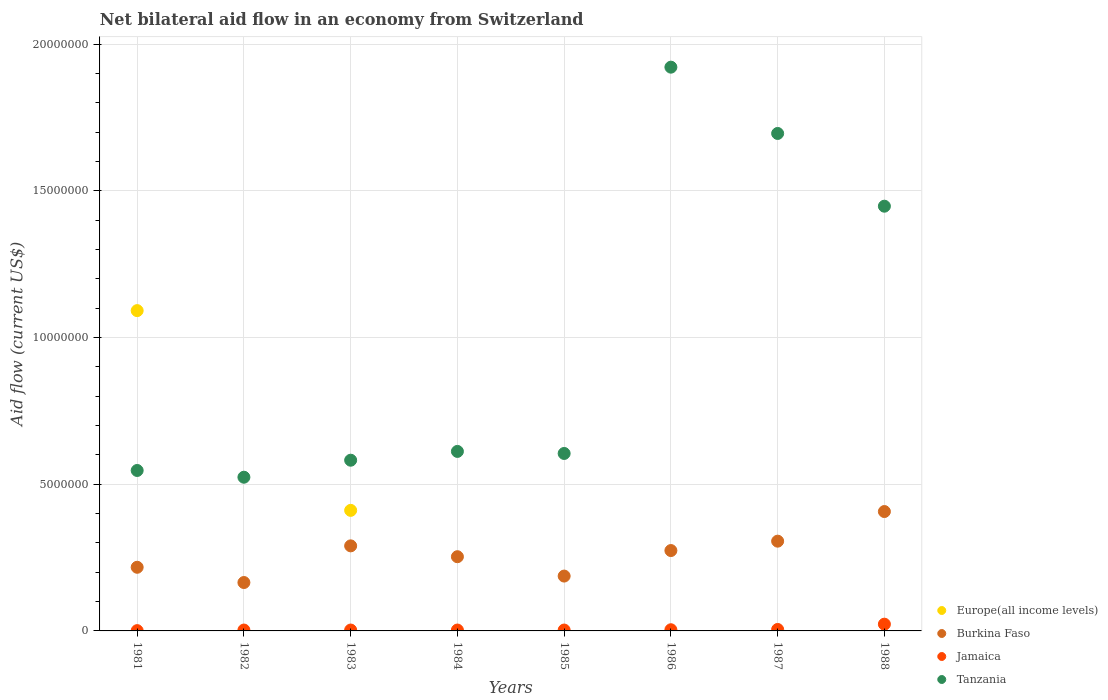What is the net bilateral aid flow in Jamaica in 1983?
Give a very brief answer. 3.00e+04. Across all years, what is the maximum net bilateral aid flow in Tanzania?
Provide a succinct answer. 1.92e+07. Across all years, what is the minimum net bilateral aid flow in Tanzania?
Offer a very short reply. 5.24e+06. What is the total net bilateral aid flow in Burkina Faso in the graph?
Provide a short and direct response. 2.10e+07. What is the difference between the net bilateral aid flow in Burkina Faso in 1982 and that in 1983?
Keep it short and to the point. -1.25e+06. What is the difference between the net bilateral aid flow in Europe(all income levels) in 1984 and the net bilateral aid flow in Burkina Faso in 1985?
Ensure brevity in your answer.  -1.87e+06. What is the average net bilateral aid flow in Jamaica per year?
Make the answer very short. 5.62e+04. In the year 1981, what is the difference between the net bilateral aid flow in Tanzania and net bilateral aid flow in Burkina Faso?
Your answer should be compact. 3.30e+06. In how many years, is the net bilateral aid flow in Europe(all income levels) greater than 15000000 US$?
Ensure brevity in your answer.  0. What is the ratio of the net bilateral aid flow in Burkina Faso in 1984 to that in 1988?
Offer a terse response. 0.62. Is the net bilateral aid flow in Jamaica in 1984 less than that in 1986?
Your response must be concise. Yes. What is the difference between the highest and the lowest net bilateral aid flow in Burkina Faso?
Your answer should be compact. 2.42e+06. Is it the case that in every year, the sum of the net bilateral aid flow in Jamaica and net bilateral aid flow in Europe(all income levels)  is greater than the sum of net bilateral aid flow in Burkina Faso and net bilateral aid flow in Tanzania?
Provide a succinct answer. No. Is the net bilateral aid flow in Jamaica strictly less than the net bilateral aid flow in Europe(all income levels) over the years?
Give a very brief answer. No. What is the difference between two consecutive major ticks on the Y-axis?
Offer a terse response. 5.00e+06. Does the graph contain any zero values?
Ensure brevity in your answer.  Yes. How are the legend labels stacked?
Keep it short and to the point. Vertical. What is the title of the graph?
Provide a short and direct response. Net bilateral aid flow in an economy from Switzerland. What is the label or title of the X-axis?
Ensure brevity in your answer.  Years. What is the label or title of the Y-axis?
Ensure brevity in your answer.  Aid flow (current US$). What is the Aid flow (current US$) in Europe(all income levels) in 1981?
Your response must be concise. 1.09e+07. What is the Aid flow (current US$) in Burkina Faso in 1981?
Your response must be concise. 2.17e+06. What is the Aid flow (current US$) in Jamaica in 1981?
Make the answer very short. 10000. What is the Aid flow (current US$) in Tanzania in 1981?
Offer a very short reply. 5.47e+06. What is the Aid flow (current US$) of Burkina Faso in 1982?
Provide a succinct answer. 1.65e+06. What is the Aid flow (current US$) of Tanzania in 1982?
Your response must be concise. 5.24e+06. What is the Aid flow (current US$) of Europe(all income levels) in 1983?
Provide a short and direct response. 4.11e+06. What is the Aid flow (current US$) in Burkina Faso in 1983?
Ensure brevity in your answer.  2.90e+06. What is the Aid flow (current US$) in Jamaica in 1983?
Provide a succinct answer. 3.00e+04. What is the Aid flow (current US$) in Tanzania in 1983?
Give a very brief answer. 5.82e+06. What is the Aid flow (current US$) in Europe(all income levels) in 1984?
Provide a short and direct response. 0. What is the Aid flow (current US$) of Burkina Faso in 1984?
Provide a succinct answer. 2.53e+06. What is the Aid flow (current US$) in Tanzania in 1984?
Make the answer very short. 6.12e+06. What is the Aid flow (current US$) in Burkina Faso in 1985?
Ensure brevity in your answer.  1.87e+06. What is the Aid flow (current US$) of Jamaica in 1985?
Make the answer very short. 3.00e+04. What is the Aid flow (current US$) in Tanzania in 1985?
Offer a terse response. 6.05e+06. What is the Aid flow (current US$) in Burkina Faso in 1986?
Ensure brevity in your answer.  2.74e+06. What is the Aid flow (current US$) of Tanzania in 1986?
Your response must be concise. 1.92e+07. What is the Aid flow (current US$) of Burkina Faso in 1987?
Offer a terse response. 3.06e+06. What is the Aid flow (current US$) in Tanzania in 1987?
Make the answer very short. 1.70e+07. What is the Aid flow (current US$) of Europe(all income levels) in 1988?
Your answer should be very brief. 0. What is the Aid flow (current US$) in Burkina Faso in 1988?
Your answer should be very brief. 4.07e+06. What is the Aid flow (current US$) in Tanzania in 1988?
Keep it short and to the point. 1.45e+07. Across all years, what is the maximum Aid flow (current US$) of Europe(all income levels)?
Give a very brief answer. 1.09e+07. Across all years, what is the maximum Aid flow (current US$) in Burkina Faso?
Ensure brevity in your answer.  4.07e+06. Across all years, what is the maximum Aid flow (current US$) in Jamaica?
Provide a short and direct response. 2.30e+05. Across all years, what is the maximum Aid flow (current US$) in Tanzania?
Provide a succinct answer. 1.92e+07. Across all years, what is the minimum Aid flow (current US$) in Europe(all income levels)?
Provide a succinct answer. 0. Across all years, what is the minimum Aid flow (current US$) of Burkina Faso?
Your response must be concise. 1.65e+06. Across all years, what is the minimum Aid flow (current US$) in Tanzania?
Offer a terse response. 5.24e+06. What is the total Aid flow (current US$) in Europe(all income levels) in the graph?
Your answer should be very brief. 1.50e+07. What is the total Aid flow (current US$) in Burkina Faso in the graph?
Provide a succinct answer. 2.10e+07. What is the total Aid flow (current US$) of Tanzania in the graph?
Your answer should be very brief. 7.94e+07. What is the difference between the Aid flow (current US$) of Burkina Faso in 1981 and that in 1982?
Your answer should be compact. 5.20e+05. What is the difference between the Aid flow (current US$) in Jamaica in 1981 and that in 1982?
Ensure brevity in your answer.  -2.00e+04. What is the difference between the Aid flow (current US$) of Tanzania in 1981 and that in 1982?
Your answer should be compact. 2.30e+05. What is the difference between the Aid flow (current US$) of Europe(all income levels) in 1981 and that in 1983?
Offer a very short reply. 6.81e+06. What is the difference between the Aid flow (current US$) in Burkina Faso in 1981 and that in 1983?
Your answer should be very brief. -7.30e+05. What is the difference between the Aid flow (current US$) of Jamaica in 1981 and that in 1983?
Provide a succinct answer. -2.00e+04. What is the difference between the Aid flow (current US$) of Tanzania in 1981 and that in 1983?
Ensure brevity in your answer.  -3.50e+05. What is the difference between the Aid flow (current US$) of Burkina Faso in 1981 and that in 1984?
Provide a short and direct response. -3.60e+05. What is the difference between the Aid flow (current US$) of Tanzania in 1981 and that in 1984?
Provide a succinct answer. -6.50e+05. What is the difference between the Aid flow (current US$) in Burkina Faso in 1981 and that in 1985?
Offer a terse response. 3.00e+05. What is the difference between the Aid flow (current US$) in Tanzania in 1981 and that in 1985?
Provide a short and direct response. -5.80e+05. What is the difference between the Aid flow (current US$) in Burkina Faso in 1981 and that in 1986?
Provide a short and direct response. -5.70e+05. What is the difference between the Aid flow (current US$) of Jamaica in 1981 and that in 1986?
Offer a very short reply. -3.00e+04. What is the difference between the Aid flow (current US$) of Tanzania in 1981 and that in 1986?
Make the answer very short. -1.38e+07. What is the difference between the Aid flow (current US$) in Burkina Faso in 1981 and that in 1987?
Offer a terse response. -8.90e+05. What is the difference between the Aid flow (current US$) of Jamaica in 1981 and that in 1987?
Give a very brief answer. -4.00e+04. What is the difference between the Aid flow (current US$) of Tanzania in 1981 and that in 1987?
Ensure brevity in your answer.  -1.15e+07. What is the difference between the Aid flow (current US$) of Burkina Faso in 1981 and that in 1988?
Give a very brief answer. -1.90e+06. What is the difference between the Aid flow (current US$) of Tanzania in 1981 and that in 1988?
Make the answer very short. -9.01e+06. What is the difference between the Aid flow (current US$) of Burkina Faso in 1982 and that in 1983?
Your answer should be very brief. -1.25e+06. What is the difference between the Aid flow (current US$) in Tanzania in 1982 and that in 1983?
Offer a terse response. -5.80e+05. What is the difference between the Aid flow (current US$) in Burkina Faso in 1982 and that in 1984?
Offer a very short reply. -8.80e+05. What is the difference between the Aid flow (current US$) of Jamaica in 1982 and that in 1984?
Ensure brevity in your answer.  0. What is the difference between the Aid flow (current US$) in Tanzania in 1982 and that in 1984?
Keep it short and to the point. -8.80e+05. What is the difference between the Aid flow (current US$) of Burkina Faso in 1982 and that in 1985?
Your answer should be very brief. -2.20e+05. What is the difference between the Aid flow (current US$) of Jamaica in 1982 and that in 1985?
Your response must be concise. 0. What is the difference between the Aid flow (current US$) of Tanzania in 1982 and that in 1985?
Your answer should be very brief. -8.10e+05. What is the difference between the Aid flow (current US$) in Burkina Faso in 1982 and that in 1986?
Make the answer very short. -1.09e+06. What is the difference between the Aid flow (current US$) of Jamaica in 1982 and that in 1986?
Your response must be concise. -10000. What is the difference between the Aid flow (current US$) in Tanzania in 1982 and that in 1986?
Make the answer very short. -1.40e+07. What is the difference between the Aid flow (current US$) in Burkina Faso in 1982 and that in 1987?
Your answer should be very brief. -1.41e+06. What is the difference between the Aid flow (current US$) in Tanzania in 1982 and that in 1987?
Your response must be concise. -1.17e+07. What is the difference between the Aid flow (current US$) of Burkina Faso in 1982 and that in 1988?
Ensure brevity in your answer.  -2.42e+06. What is the difference between the Aid flow (current US$) in Tanzania in 1982 and that in 1988?
Offer a very short reply. -9.24e+06. What is the difference between the Aid flow (current US$) in Jamaica in 1983 and that in 1984?
Your answer should be very brief. 0. What is the difference between the Aid flow (current US$) in Tanzania in 1983 and that in 1984?
Provide a short and direct response. -3.00e+05. What is the difference between the Aid flow (current US$) of Burkina Faso in 1983 and that in 1985?
Keep it short and to the point. 1.03e+06. What is the difference between the Aid flow (current US$) of Tanzania in 1983 and that in 1985?
Make the answer very short. -2.30e+05. What is the difference between the Aid flow (current US$) in Tanzania in 1983 and that in 1986?
Provide a succinct answer. -1.34e+07. What is the difference between the Aid flow (current US$) in Jamaica in 1983 and that in 1987?
Keep it short and to the point. -2.00e+04. What is the difference between the Aid flow (current US$) of Tanzania in 1983 and that in 1987?
Offer a very short reply. -1.11e+07. What is the difference between the Aid flow (current US$) in Burkina Faso in 1983 and that in 1988?
Your answer should be compact. -1.17e+06. What is the difference between the Aid flow (current US$) in Tanzania in 1983 and that in 1988?
Ensure brevity in your answer.  -8.66e+06. What is the difference between the Aid flow (current US$) of Jamaica in 1984 and that in 1985?
Your response must be concise. 0. What is the difference between the Aid flow (current US$) of Tanzania in 1984 and that in 1985?
Provide a short and direct response. 7.00e+04. What is the difference between the Aid flow (current US$) in Tanzania in 1984 and that in 1986?
Provide a succinct answer. -1.31e+07. What is the difference between the Aid flow (current US$) of Burkina Faso in 1984 and that in 1987?
Ensure brevity in your answer.  -5.30e+05. What is the difference between the Aid flow (current US$) of Tanzania in 1984 and that in 1987?
Give a very brief answer. -1.08e+07. What is the difference between the Aid flow (current US$) in Burkina Faso in 1984 and that in 1988?
Your answer should be very brief. -1.54e+06. What is the difference between the Aid flow (current US$) in Tanzania in 1984 and that in 1988?
Your response must be concise. -8.36e+06. What is the difference between the Aid flow (current US$) of Burkina Faso in 1985 and that in 1986?
Provide a succinct answer. -8.70e+05. What is the difference between the Aid flow (current US$) in Tanzania in 1985 and that in 1986?
Your answer should be very brief. -1.32e+07. What is the difference between the Aid flow (current US$) of Burkina Faso in 1985 and that in 1987?
Offer a terse response. -1.19e+06. What is the difference between the Aid flow (current US$) of Tanzania in 1985 and that in 1987?
Keep it short and to the point. -1.09e+07. What is the difference between the Aid flow (current US$) of Burkina Faso in 1985 and that in 1988?
Your answer should be very brief. -2.20e+06. What is the difference between the Aid flow (current US$) in Jamaica in 1985 and that in 1988?
Ensure brevity in your answer.  -2.00e+05. What is the difference between the Aid flow (current US$) of Tanzania in 1985 and that in 1988?
Keep it short and to the point. -8.43e+06. What is the difference between the Aid flow (current US$) of Burkina Faso in 1986 and that in 1987?
Your response must be concise. -3.20e+05. What is the difference between the Aid flow (current US$) of Jamaica in 1986 and that in 1987?
Offer a terse response. -10000. What is the difference between the Aid flow (current US$) of Tanzania in 1986 and that in 1987?
Provide a succinct answer. 2.26e+06. What is the difference between the Aid flow (current US$) in Burkina Faso in 1986 and that in 1988?
Your answer should be compact. -1.33e+06. What is the difference between the Aid flow (current US$) of Jamaica in 1986 and that in 1988?
Your response must be concise. -1.90e+05. What is the difference between the Aid flow (current US$) in Tanzania in 1986 and that in 1988?
Provide a short and direct response. 4.74e+06. What is the difference between the Aid flow (current US$) in Burkina Faso in 1987 and that in 1988?
Make the answer very short. -1.01e+06. What is the difference between the Aid flow (current US$) of Tanzania in 1987 and that in 1988?
Make the answer very short. 2.48e+06. What is the difference between the Aid flow (current US$) in Europe(all income levels) in 1981 and the Aid flow (current US$) in Burkina Faso in 1982?
Your answer should be very brief. 9.27e+06. What is the difference between the Aid flow (current US$) in Europe(all income levels) in 1981 and the Aid flow (current US$) in Jamaica in 1982?
Offer a terse response. 1.09e+07. What is the difference between the Aid flow (current US$) of Europe(all income levels) in 1981 and the Aid flow (current US$) of Tanzania in 1982?
Offer a terse response. 5.68e+06. What is the difference between the Aid flow (current US$) in Burkina Faso in 1981 and the Aid flow (current US$) in Jamaica in 1982?
Keep it short and to the point. 2.14e+06. What is the difference between the Aid flow (current US$) of Burkina Faso in 1981 and the Aid flow (current US$) of Tanzania in 1982?
Offer a terse response. -3.07e+06. What is the difference between the Aid flow (current US$) in Jamaica in 1981 and the Aid flow (current US$) in Tanzania in 1982?
Give a very brief answer. -5.23e+06. What is the difference between the Aid flow (current US$) in Europe(all income levels) in 1981 and the Aid flow (current US$) in Burkina Faso in 1983?
Make the answer very short. 8.02e+06. What is the difference between the Aid flow (current US$) of Europe(all income levels) in 1981 and the Aid flow (current US$) of Jamaica in 1983?
Your answer should be very brief. 1.09e+07. What is the difference between the Aid flow (current US$) in Europe(all income levels) in 1981 and the Aid flow (current US$) in Tanzania in 1983?
Provide a short and direct response. 5.10e+06. What is the difference between the Aid flow (current US$) of Burkina Faso in 1981 and the Aid flow (current US$) of Jamaica in 1983?
Keep it short and to the point. 2.14e+06. What is the difference between the Aid flow (current US$) in Burkina Faso in 1981 and the Aid flow (current US$) in Tanzania in 1983?
Your answer should be compact. -3.65e+06. What is the difference between the Aid flow (current US$) of Jamaica in 1981 and the Aid flow (current US$) of Tanzania in 1983?
Offer a very short reply. -5.81e+06. What is the difference between the Aid flow (current US$) of Europe(all income levels) in 1981 and the Aid flow (current US$) of Burkina Faso in 1984?
Keep it short and to the point. 8.39e+06. What is the difference between the Aid flow (current US$) of Europe(all income levels) in 1981 and the Aid flow (current US$) of Jamaica in 1984?
Provide a succinct answer. 1.09e+07. What is the difference between the Aid flow (current US$) of Europe(all income levels) in 1981 and the Aid flow (current US$) of Tanzania in 1984?
Make the answer very short. 4.80e+06. What is the difference between the Aid flow (current US$) in Burkina Faso in 1981 and the Aid flow (current US$) in Jamaica in 1984?
Offer a very short reply. 2.14e+06. What is the difference between the Aid flow (current US$) of Burkina Faso in 1981 and the Aid flow (current US$) of Tanzania in 1984?
Provide a succinct answer. -3.95e+06. What is the difference between the Aid flow (current US$) in Jamaica in 1981 and the Aid flow (current US$) in Tanzania in 1984?
Your response must be concise. -6.11e+06. What is the difference between the Aid flow (current US$) of Europe(all income levels) in 1981 and the Aid flow (current US$) of Burkina Faso in 1985?
Your answer should be compact. 9.05e+06. What is the difference between the Aid flow (current US$) in Europe(all income levels) in 1981 and the Aid flow (current US$) in Jamaica in 1985?
Offer a terse response. 1.09e+07. What is the difference between the Aid flow (current US$) of Europe(all income levels) in 1981 and the Aid flow (current US$) of Tanzania in 1985?
Ensure brevity in your answer.  4.87e+06. What is the difference between the Aid flow (current US$) in Burkina Faso in 1981 and the Aid flow (current US$) in Jamaica in 1985?
Your answer should be very brief. 2.14e+06. What is the difference between the Aid flow (current US$) of Burkina Faso in 1981 and the Aid flow (current US$) of Tanzania in 1985?
Provide a short and direct response. -3.88e+06. What is the difference between the Aid flow (current US$) in Jamaica in 1981 and the Aid flow (current US$) in Tanzania in 1985?
Keep it short and to the point. -6.04e+06. What is the difference between the Aid flow (current US$) of Europe(all income levels) in 1981 and the Aid flow (current US$) of Burkina Faso in 1986?
Provide a short and direct response. 8.18e+06. What is the difference between the Aid flow (current US$) of Europe(all income levels) in 1981 and the Aid flow (current US$) of Jamaica in 1986?
Give a very brief answer. 1.09e+07. What is the difference between the Aid flow (current US$) in Europe(all income levels) in 1981 and the Aid flow (current US$) in Tanzania in 1986?
Your answer should be very brief. -8.30e+06. What is the difference between the Aid flow (current US$) of Burkina Faso in 1981 and the Aid flow (current US$) of Jamaica in 1986?
Provide a succinct answer. 2.13e+06. What is the difference between the Aid flow (current US$) in Burkina Faso in 1981 and the Aid flow (current US$) in Tanzania in 1986?
Make the answer very short. -1.70e+07. What is the difference between the Aid flow (current US$) of Jamaica in 1981 and the Aid flow (current US$) of Tanzania in 1986?
Your response must be concise. -1.92e+07. What is the difference between the Aid flow (current US$) of Europe(all income levels) in 1981 and the Aid flow (current US$) of Burkina Faso in 1987?
Provide a short and direct response. 7.86e+06. What is the difference between the Aid flow (current US$) of Europe(all income levels) in 1981 and the Aid flow (current US$) of Jamaica in 1987?
Make the answer very short. 1.09e+07. What is the difference between the Aid flow (current US$) of Europe(all income levels) in 1981 and the Aid flow (current US$) of Tanzania in 1987?
Offer a terse response. -6.04e+06. What is the difference between the Aid flow (current US$) of Burkina Faso in 1981 and the Aid flow (current US$) of Jamaica in 1987?
Provide a succinct answer. 2.12e+06. What is the difference between the Aid flow (current US$) in Burkina Faso in 1981 and the Aid flow (current US$) in Tanzania in 1987?
Offer a very short reply. -1.48e+07. What is the difference between the Aid flow (current US$) in Jamaica in 1981 and the Aid flow (current US$) in Tanzania in 1987?
Keep it short and to the point. -1.70e+07. What is the difference between the Aid flow (current US$) of Europe(all income levels) in 1981 and the Aid flow (current US$) of Burkina Faso in 1988?
Offer a very short reply. 6.85e+06. What is the difference between the Aid flow (current US$) in Europe(all income levels) in 1981 and the Aid flow (current US$) in Jamaica in 1988?
Your response must be concise. 1.07e+07. What is the difference between the Aid flow (current US$) of Europe(all income levels) in 1981 and the Aid flow (current US$) of Tanzania in 1988?
Provide a short and direct response. -3.56e+06. What is the difference between the Aid flow (current US$) in Burkina Faso in 1981 and the Aid flow (current US$) in Jamaica in 1988?
Offer a very short reply. 1.94e+06. What is the difference between the Aid flow (current US$) of Burkina Faso in 1981 and the Aid flow (current US$) of Tanzania in 1988?
Give a very brief answer. -1.23e+07. What is the difference between the Aid flow (current US$) in Jamaica in 1981 and the Aid flow (current US$) in Tanzania in 1988?
Provide a short and direct response. -1.45e+07. What is the difference between the Aid flow (current US$) of Burkina Faso in 1982 and the Aid flow (current US$) of Jamaica in 1983?
Provide a short and direct response. 1.62e+06. What is the difference between the Aid flow (current US$) in Burkina Faso in 1982 and the Aid flow (current US$) in Tanzania in 1983?
Your response must be concise. -4.17e+06. What is the difference between the Aid flow (current US$) of Jamaica in 1982 and the Aid flow (current US$) of Tanzania in 1983?
Your response must be concise. -5.79e+06. What is the difference between the Aid flow (current US$) of Burkina Faso in 1982 and the Aid flow (current US$) of Jamaica in 1984?
Give a very brief answer. 1.62e+06. What is the difference between the Aid flow (current US$) in Burkina Faso in 1982 and the Aid flow (current US$) in Tanzania in 1984?
Provide a succinct answer. -4.47e+06. What is the difference between the Aid flow (current US$) in Jamaica in 1982 and the Aid flow (current US$) in Tanzania in 1984?
Your answer should be compact. -6.09e+06. What is the difference between the Aid flow (current US$) of Burkina Faso in 1982 and the Aid flow (current US$) of Jamaica in 1985?
Offer a terse response. 1.62e+06. What is the difference between the Aid flow (current US$) in Burkina Faso in 1982 and the Aid flow (current US$) in Tanzania in 1985?
Offer a very short reply. -4.40e+06. What is the difference between the Aid flow (current US$) in Jamaica in 1982 and the Aid flow (current US$) in Tanzania in 1985?
Your answer should be compact. -6.02e+06. What is the difference between the Aid flow (current US$) of Burkina Faso in 1982 and the Aid flow (current US$) of Jamaica in 1986?
Your answer should be compact. 1.61e+06. What is the difference between the Aid flow (current US$) of Burkina Faso in 1982 and the Aid flow (current US$) of Tanzania in 1986?
Give a very brief answer. -1.76e+07. What is the difference between the Aid flow (current US$) in Jamaica in 1982 and the Aid flow (current US$) in Tanzania in 1986?
Provide a succinct answer. -1.92e+07. What is the difference between the Aid flow (current US$) in Burkina Faso in 1982 and the Aid flow (current US$) in Jamaica in 1987?
Offer a very short reply. 1.60e+06. What is the difference between the Aid flow (current US$) of Burkina Faso in 1982 and the Aid flow (current US$) of Tanzania in 1987?
Ensure brevity in your answer.  -1.53e+07. What is the difference between the Aid flow (current US$) of Jamaica in 1982 and the Aid flow (current US$) of Tanzania in 1987?
Provide a short and direct response. -1.69e+07. What is the difference between the Aid flow (current US$) in Burkina Faso in 1982 and the Aid flow (current US$) in Jamaica in 1988?
Offer a very short reply. 1.42e+06. What is the difference between the Aid flow (current US$) of Burkina Faso in 1982 and the Aid flow (current US$) of Tanzania in 1988?
Provide a short and direct response. -1.28e+07. What is the difference between the Aid flow (current US$) in Jamaica in 1982 and the Aid flow (current US$) in Tanzania in 1988?
Offer a very short reply. -1.44e+07. What is the difference between the Aid flow (current US$) of Europe(all income levels) in 1983 and the Aid flow (current US$) of Burkina Faso in 1984?
Provide a succinct answer. 1.58e+06. What is the difference between the Aid flow (current US$) in Europe(all income levels) in 1983 and the Aid flow (current US$) in Jamaica in 1984?
Keep it short and to the point. 4.08e+06. What is the difference between the Aid flow (current US$) of Europe(all income levels) in 1983 and the Aid flow (current US$) of Tanzania in 1984?
Provide a succinct answer. -2.01e+06. What is the difference between the Aid flow (current US$) in Burkina Faso in 1983 and the Aid flow (current US$) in Jamaica in 1984?
Give a very brief answer. 2.87e+06. What is the difference between the Aid flow (current US$) of Burkina Faso in 1983 and the Aid flow (current US$) of Tanzania in 1984?
Give a very brief answer. -3.22e+06. What is the difference between the Aid flow (current US$) in Jamaica in 1983 and the Aid flow (current US$) in Tanzania in 1984?
Keep it short and to the point. -6.09e+06. What is the difference between the Aid flow (current US$) of Europe(all income levels) in 1983 and the Aid flow (current US$) of Burkina Faso in 1985?
Give a very brief answer. 2.24e+06. What is the difference between the Aid flow (current US$) of Europe(all income levels) in 1983 and the Aid flow (current US$) of Jamaica in 1985?
Provide a succinct answer. 4.08e+06. What is the difference between the Aid flow (current US$) in Europe(all income levels) in 1983 and the Aid flow (current US$) in Tanzania in 1985?
Keep it short and to the point. -1.94e+06. What is the difference between the Aid flow (current US$) of Burkina Faso in 1983 and the Aid flow (current US$) of Jamaica in 1985?
Offer a very short reply. 2.87e+06. What is the difference between the Aid flow (current US$) in Burkina Faso in 1983 and the Aid flow (current US$) in Tanzania in 1985?
Offer a terse response. -3.15e+06. What is the difference between the Aid flow (current US$) of Jamaica in 1983 and the Aid flow (current US$) of Tanzania in 1985?
Offer a terse response. -6.02e+06. What is the difference between the Aid flow (current US$) of Europe(all income levels) in 1983 and the Aid flow (current US$) of Burkina Faso in 1986?
Offer a terse response. 1.37e+06. What is the difference between the Aid flow (current US$) of Europe(all income levels) in 1983 and the Aid flow (current US$) of Jamaica in 1986?
Offer a terse response. 4.07e+06. What is the difference between the Aid flow (current US$) in Europe(all income levels) in 1983 and the Aid flow (current US$) in Tanzania in 1986?
Provide a short and direct response. -1.51e+07. What is the difference between the Aid flow (current US$) of Burkina Faso in 1983 and the Aid flow (current US$) of Jamaica in 1986?
Keep it short and to the point. 2.86e+06. What is the difference between the Aid flow (current US$) of Burkina Faso in 1983 and the Aid flow (current US$) of Tanzania in 1986?
Offer a very short reply. -1.63e+07. What is the difference between the Aid flow (current US$) in Jamaica in 1983 and the Aid flow (current US$) in Tanzania in 1986?
Ensure brevity in your answer.  -1.92e+07. What is the difference between the Aid flow (current US$) in Europe(all income levels) in 1983 and the Aid flow (current US$) in Burkina Faso in 1987?
Give a very brief answer. 1.05e+06. What is the difference between the Aid flow (current US$) in Europe(all income levels) in 1983 and the Aid flow (current US$) in Jamaica in 1987?
Offer a very short reply. 4.06e+06. What is the difference between the Aid flow (current US$) of Europe(all income levels) in 1983 and the Aid flow (current US$) of Tanzania in 1987?
Your answer should be compact. -1.28e+07. What is the difference between the Aid flow (current US$) of Burkina Faso in 1983 and the Aid flow (current US$) of Jamaica in 1987?
Keep it short and to the point. 2.85e+06. What is the difference between the Aid flow (current US$) in Burkina Faso in 1983 and the Aid flow (current US$) in Tanzania in 1987?
Offer a very short reply. -1.41e+07. What is the difference between the Aid flow (current US$) in Jamaica in 1983 and the Aid flow (current US$) in Tanzania in 1987?
Give a very brief answer. -1.69e+07. What is the difference between the Aid flow (current US$) of Europe(all income levels) in 1983 and the Aid flow (current US$) of Jamaica in 1988?
Offer a terse response. 3.88e+06. What is the difference between the Aid flow (current US$) in Europe(all income levels) in 1983 and the Aid flow (current US$) in Tanzania in 1988?
Offer a terse response. -1.04e+07. What is the difference between the Aid flow (current US$) in Burkina Faso in 1983 and the Aid flow (current US$) in Jamaica in 1988?
Your answer should be very brief. 2.67e+06. What is the difference between the Aid flow (current US$) in Burkina Faso in 1983 and the Aid flow (current US$) in Tanzania in 1988?
Provide a succinct answer. -1.16e+07. What is the difference between the Aid flow (current US$) of Jamaica in 1983 and the Aid flow (current US$) of Tanzania in 1988?
Keep it short and to the point. -1.44e+07. What is the difference between the Aid flow (current US$) in Burkina Faso in 1984 and the Aid flow (current US$) in Jamaica in 1985?
Your answer should be very brief. 2.50e+06. What is the difference between the Aid flow (current US$) of Burkina Faso in 1984 and the Aid flow (current US$) of Tanzania in 1985?
Provide a succinct answer. -3.52e+06. What is the difference between the Aid flow (current US$) in Jamaica in 1984 and the Aid flow (current US$) in Tanzania in 1985?
Keep it short and to the point. -6.02e+06. What is the difference between the Aid flow (current US$) in Burkina Faso in 1984 and the Aid flow (current US$) in Jamaica in 1986?
Ensure brevity in your answer.  2.49e+06. What is the difference between the Aid flow (current US$) of Burkina Faso in 1984 and the Aid flow (current US$) of Tanzania in 1986?
Your response must be concise. -1.67e+07. What is the difference between the Aid flow (current US$) in Jamaica in 1984 and the Aid flow (current US$) in Tanzania in 1986?
Your response must be concise. -1.92e+07. What is the difference between the Aid flow (current US$) of Burkina Faso in 1984 and the Aid flow (current US$) of Jamaica in 1987?
Your answer should be very brief. 2.48e+06. What is the difference between the Aid flow (current US$) in Burkina Faso in 1984 and the Aid flow (current US$) in Tanzania in 1987?
Keep it short and to the point. -1.44e+07. What is the difference between the Aid flow (current US$) in Jamaica in 1984 and the Aid flow (current US$) in Tanzania in 1987?
Provide a succinct answer. -1.69e+07. What is the difference between the Aid flow (current US$) of Burkina Faso in 1984 and the Aid flow (current US$) of Jamaica in 1988?
Your answer should be compact. 2.30e+06. What is the difference between the Aid flow (current US$) in Burkina Faso in 1984 and the Aid flow (current US$) in Tanzania in 1988?
Ensure brevity in your answer.  -1.20e+07. What is the difference between the Aid flow (current US$) in Jamaica in 1984 and the Aid flow (current US$) in Tanzania in 1988?
Your answer should be compact. -1.44e+07. What is the difference between the Aid flow (current US$) of Burkina Faso in 1985 and the Aid flow (current US$) of Jamaica in 1986?
Keep it short and to the point. 1.83e+06. What is the difference between the Aid flow (current US$) in Burkina Faso in 1985 and the Aid flow (current US$) in Tanzania in 1986?
Provide a short and direct response. -1.74e+07. What is the difference between the Aid flow (current US$) in Jamaica in 1985 and the Aid flow (current US$) in Tanzania in 1986?
Offer a very short reply. -1.92e+07. What is the difference between the Aid flow (current US$) in Burkina Faso in 1985 and the Aid flow (current US$) in Jamaica in 1987?
Provide a short and direct response. 1.82e+06. What is the difference between the Aid flow (current US$) in Burkina Faso in 1985 and the Aid flow (current US$) in Tanzania in 1987?
Make the answer very short. -1.51e+07. What is the difference between the Aid flow (current US$) of Jamaica in 1985 and the Aid flow (current US$) of Tanzania in 1987?
Make the answer very short. -1.69e+07. What is the difference between the Aid flow (current US$) of Burkina Faso in 1985 and the Aid flow (current US$) of Jamaica in 1988?
Make the answer very short. 1.64e+06. What is the difference between the Aid flow (current US$) in Burkina Faso in 1985 and the Aid flow (current US$) in Tanzania in 1988?
Provide a short and direct response. -1.26e+07. What is the difference between the Aid flow (current US$) of Jamaica in 1985 and the Aid flow (current US$) of Tanzania in 1988?
Make the answer very short. -1.44e+07. What is the difference between the Aid flow (current US$) of Burkina Faso in 1986 and the Aid flow (current US$) of Jamaica in 1987?
Keep it short and to the point. 2.69e+06. What is the difference between the Aid flow (current US$) in Burkina Faso in 1986 and the Aid flow (current US$) in Tanzania in 1987?
Make the answer very short. -1.42e+07. What is the difference between the Aid flow (current US$) of Jamaica in 1986 and the Aid flow (current US$) of Tanzania in 1987?
Offer a very short reply. -1.69e+07. What is the difference between the Aid flow (current US$) in Burkina Faso in 1986 and the Aid flow (current US$) in Jamaica in 1988?
Provide a short and direct response. 2.51e+06. What is the difference between the Aid flow (current US$) in Burkina Faso in 1986 and the Aid flow (current US$) in Tanzania in 1988?
Make the answer very short. -1.17e+07. What is the difference between the Aid flow (current US$) of Jamaica in 1986 and the Aid flow (current US$) of Tanzania in 1988?
Provide a succinct answer. -1.44e+07. What is the difference between the Aid flow (current US$) in Burkina Faso in 1987 and the Aid flow (current US$) in Jamaica in 1988?
Offer a very short reply. 2.83e+06. What is the difference between the Aid flow (current US$) in Burkina Faso in 1987 and the Aid flow (current US$) in Tanzania in 1988?
Offer a very short reply. -1.14e+07. What is the difference between the Aid flow (current US$) in Jamaica in 1987 and the Aid flow (current US$) in Tanzania in 1988?
Offer a very short reply. -1.44e+07. What is the average Aid flow (current US$) in Europe(all income levels) per year?
Keep it short and to the point. 1.88e+06. What is the average Aid flow (current US$) of Burkina Faso per year?
Your answer should be compact. 2.62e+06. What is the average Aid flow (current US$) of Jamaica per year?
Make the answer very short. 5.62e+04. What is the average Aid flow (current US$) in Tanzania per year?
Ensure brevity in your answer.  9.92e+06. In the year 1981, what is the difference between the Aid flow (current US$) in Europe(all income levels) and Aid flow (current US$) in Burkina Faso?
Offer a terse response. 8.75e+06. In the year 1981, what is the difference between the Aid flow (current US$) in Europe(all income levels) and Aid flow (current US$) in Jamaica?
Provide a succinct answer. 1.09e+07. In the year 1981, what is the difference between the Aid flow (current US$) in Europe(all income levels) and Aid flow (current US$) in Tanzania?
Provide a short and direct response. 5.45e+06. In the year 1981, what is the difference between the Aid flow (current US$) in Burkina Faso and Aid flow (current US$) in Jamaica?
Your answer should be very brief. 2.16e+06. In the year 1981, what is the difference between the Aid flow (current US$) of Burkina Faso and Aid flow (current US$) of Tanzania?
Give a very brief answer. -3.30e+06. In the year 1981, what is the difference between the Aid flow (current US$) in Jamaica and Aid flow (current US$) in Tanzania?
Make the answer very short. -5.46e+06. In the year 1982, what is the difference between the Aid flow (current US$) of Burkina Faso and Aid flow (current US$) of Jamaica?
Provide a succinct answer. 1.62e+06. In the year 1982, what is the difference between the Aid flow (current US$) in Burkina Faso and Aid flow (current US$) in Tanzania?
Keep it short and to the point. -3.59e+06. In the year 1982, what is the difference between the Aid flow (current US$) of Jamaica and Aid flow (current US$) of Tanzania?
Provide a succinct answer. -5.21e+06. In the year 1983, what is the difference between the Aid flow (current US$) of Europe(all income levels) and Aid flow (current US$) of Burkina Faso?
Keep it short and to the point. 1.21e+06. In the year 1983, what is the difference between the Aid flow (current US$) of Europe(all income levels) and Aid flow (current US$) of Jamaica?
Make the answer very short. 4.08e+06. In the year 1983, what is the difference between the Aid flow (current US$) in Europe(all income levels) and Aid flow (current US$) in Tanzania?
Your answer should be compact. -1.71e+06. In the year 1983, what is the difference between the Aid flow (current US$) in Burkina Faso and Aid flow (current US$) in Jamaica?
Give a very brief answer. 2.87e+06. In the year 1983, what is the difference between the Aid flow (current US$) in Burkina Faso and Aid flow (current US$) in Tanzania?
Provide a succinct answer. -2.92e+06. In the year 1983, what is the difference between the Aid flow (current US$) in Jamaica and Aid flow (current US$) in Tanzania?
Make the answer very short. -5.79e+06. In the year 1984, what is the difference between the Aid flow (current US$) of Burkina Faso and Aid flow (current US$) of Jamaica?
Provide a short and direct response. 2.50e+06. In the year 1984, what is the difference between the Aid flow (current US$) of Burkina Faso and Aid flow (current US$) of Tanzania?
Offer a very short reply. -3.59e+06. In the year 1984, what is the difference between the Aid flow (current US$) in Jamaica and Aid flow (current US$) in Tanzania?
Your answer should be very brief. -6.09e+06. In the year 1985, what is the difference between the Aid flow (current US$) of Burkina Faso and Aid flow (current US$) of Jamaica?
Keep it short and to the point. 1.84e+06. In the year 1985, what is the difference between the Aid flow (current US$) of Burkina Faso and Aid flow (current US$) of Tanzania?
Your answer should be very brief. -4.18e+06. In the year 1985, what is the difference between the Aid flow (current US$) of Jamaica and Aid flow (current US$) of Tanzania?
Your response must be concise. -6.02e+06. In the year 1986, what is the difference between the Aid flow (current US$) of Burkina Faso and Aid flow (current US$) of Jamaica?
Your answer should be very brief. 2.70e+06. In the year 1986, what is the difference between the Aid flow (current US$) of Burkina Faso and Aid flow (current US$) of Tanzania?
Give a very brief answer. -1.65e+07. In the year 1986, what is the difference between the Aid flow (current US$) in Jamaica and Aid flow (current US$) in Tanzania?
Give a very brief answer. -1.92e+07. In the year 1987, what is the difference between the Aid flow (current US$) in Burkina Faso and Aid flow (current US$) in Jamaica?
Offer a very short reply. 3.01e+06. In the year 1987, what is the difference between the Aid flow (current US$) in Burkina Faso and Aid flow (current US$) in Tanzania?
Your answer should be compact. -1.39e+07. In the year 1987, what is the difference between the Aid flow (current US$) in Jamaica and Aid flow (current US$) in Tanzania?
Ensure brevity in your answer.  -1.69e+07. In the year 1988, what is the difference between the Aid flow (current US$) of Burkina Faso and Aid flow (current US$) of Jamaica?
Offer a terse response. 3.84e+06. In the year 1988, what is the difference between the Aid flow (current US$) in Burkina Faso and Aid flow (current US$) in Tanzania?
Provide a short and direct response. -1.04e+07. In the year 1988, what is the difference between the Aid flow (current US$) in Jamaica and Aid flow (current US$) in Tanzania?
Provide a short and direct response. -1.42e+07. What is the ratio of the Aid flow (current US$) of Burkina Faso in 1981 to that in 1982?
Offer a very short reply. 1.32. What is the ratio of the Aid flow (current US$) in Tanzania in 1981 to that in 1982?
Provide a short and direct response. 1.04. What is the ratio of the Aid flow (current US$) of Europe(all income levels) in 1981 to that in 1983?
Offer a terse response. 2.66. What is the ratio of the Aid flow (current US$) in Burkina Faso in 1981 to that in 1983?
Provide a succinct answer. 0.75. What is the ratio of the Aid flow (current US$) in Jamaica in 1981 to that in 1983?
Make the answer very short. 0.33. What is the ratio of the Aid flow (current US$) of Tanzania in 1981 to that in 1983?
Your response must be concise. 0.94. What is the ratio of the Aid flow (current US$) of Burkina Faso in 1981 to that in 1984?
Provide a succinct answer. 0.86. What is the ratio of the Aid flow (current US$) in Tanzania in 1981 to that in 1984?
Offer a terse response. 0.89. What is the ratio of the Aid flow (current US$) of Burkina Faso in 1981 to that in 1985?
Make the answer very short. 1.16. What is the ratio of the Aid flow (current US$) in Jamaica in 1981 to that in 1985?
Keep it short and to the point. 0.33. What is the ratio of the Aid flow (current US$) in Tanzania in 1981 to that in 1985?
Keep it short and to the point. 0.9. What is the ratio of the Aid flow (current US$) in Burkina Faso in 1981 to that in 1986?
Provide a succinct answer. 0.79. What is the ratio of the Aid flow (current US$) of Tanzania in 1981 to that in 1986?
Your response must be concise. 0.28. What is the ratio of the Aid flow (current US$) of Burkina Faso in 1981 to that in 1987?
Keep it short and to the point. 0.71. What is the ratio of the Aid flow (current US$) in Tanzania in 1981 to that in 1987?
Provide a short and direct response. 0.32. What is the ratio of the Aid flow (current US$) in Burkina Faso in 1981 to that in 1988?
Ensure brevity in your answer.  0.53. What is the ratio of the Aid flow (current US$) of Jamaica in 1981 to that in 1988?
Ensure brevity in your answer.  0.04. What is the ratio of the Aid flow (current US$) in Tanzania in 1981 to that in 1988?
Your answer should be compact. 0.38. What is the ratio of the Aid flow (current US$) in Burkina Faso in 1982 to that in 1983?
Your response must be concise. 0.57. What is the ratio of the Aid flow (current US$) of Tanzania in 1982 to that in 1983?
Offer a terse response. 0.9. What is the ratio of the Aid flow (current US$) of Burkina Faso in 1982 to that in 1984?
Ensure brevity in your answer.  0.65. What is the ratio of the Aid flow (current US$) in Jamaica in 1982 to that in 1984?
Ensure brevity in your answer.  1. What is the ratio of the Aid flow (current US$) in Tanzania in 1982 to that in 1984?
Your answer should be very brief. 0.86. What is the ratio of the Aid flow (current US$) in Burkina Faso in 1982 to that in 1985?
Give a very brief answer. 0.88. What is the ratio of the Aid flow (current US$) of Tanzania in 1982 to that in 1985?
Your answer should be compact. 0.87. What is the ratio of the Aid flow (current US$) in Burkina Faso in 1982 to that in 1986?
Give a very brief answer. 0.6. What is the ratio of the Aid flow (current US$) in Tanzania in 1982 to that in 1986?
Your response must be concise. 0.27. What is the ratio of the Aid flow (current US$) of Burkina Faso in 1982 to that in 1987?
Your response must be concise. 0.54. What is the ratio of the Aid flow (current US$) of Tanzania in 1982 to that in 1987?
Provide a succinct answer. 0.31. What is the ratio of the Aid flow (current US$) in Burkina Faso in 1982 to that in 1988?
Provide a short and direct response. 0.41. What is the ratio of the Aid flow (current US$) of Jamaica in 1982 to that in 1988?
Make the answer very short. 0.13. What is the ratio of the Aid flow (current US$) of Tanzania in 1982 to that in 1988?
Ensure brevity in your answer.  0.36. What is the ratio of the Aid flow (current US$) of Burkina Faso in 1983 to that in 1984?
Your answer should be compact. 1.15. What is the ratio of the Aid flow (current US$) in Jamaica in 1983 to that in 1984?
Make the answer very short. 1. What is the ratio of the Aid flow (current US$) of Tanzania in 1983 to that in 1984?
Your answer should be very brief. 0.95. What is the ratio of the Aid flow (current US$) in Burkina Faso in 1983 to that in 1985?
Offer a very short reply. 1.55. What is the ratio of the Aid flow (current US$) in Jamaica in 1983 to that in 1985?
Your answer should be compact. 1. What is the ratio of the Aid flow (current US$) in Burkina Faso in 1983 to that in 1986?
Offer a very short reply. 1.06. What is the ratio of the Aid flow (current US$) in Tanzania in 1983 to that in 1986?
Offer a terse response. 0.3. What is the ratio of the Aid flow (current US$) in Burkina Faso in 1983 to that in 1987?
Your response must be concise. 0.95. What is the ratio of the Aid flow (current US$) of Jamaica in 1983 to that in 1987?
Offer a very short reply. 0.6. What is the ratio of the Aid flow (current US$) in Tanzania in 1983 to that in 1987?
Provide a short and direct response. 0.34. What is the ratio of the Aid flow (current US$) of Burkina Faso in 1983 to that in 1988?
Ensure brevity in your answer.  0.71. What is the ratio of the Aid flow (current US$) of Jamaica in 1983 to that in 1988?
Your response must be concise. 0.13. What is the ratio of the Aid flow (current US$) of Tanzania in 1983 to that in 1988?
Offer a terse response. 0.4. What is the ratio of the Aid flow (current US$) in Burkina Faso in 1984 to that in 1985?
Make the answer very short. 1.35. What is the ratio of the Aid flow (current US$) in Tanzania in 1984 to that in 1985?
Make the answer very short. 1.01. What is the ratio of the Aid flow (current US$) of Burkina Faso in 1984 to that in 1986?
Provide a succinct answer. 0.92. What is the ratio of the Aid flow (current US$) of Tanzania in 1984 to that in 1986?
Ensure brevity in your answer.  0.32. What is the ratio of the Aid flow (current US$) of Burkina Faso in 1984 to that in 1987?
Keep it short and to the point. 0.83. What is the ratio of the Aid flow (current US$) of Tanzania in 1984 to that in 1987?
Give a very brief answer. 0.36. What is the ratio of the Aid flow (current US$) in Burkina Faso in 1984 to that in 1988?
Provide a short and direct response. 0.62. What is the ratio of the Aid flow (current US$) in Jamaica in 1984 to that in 1988?
Keep it short and to the point. 0.13. What is the ratio of the Aid flow (current US$) of Tanzania in 1984 to that in 1988?
Make the answer very short. 0.42. What is the ratio of the Aid flow (current US$) in Burkina Faso in 1985 to that in 1986?
Your response must be concise. 0.68. What is the ratio of the Aid flow (current US$) in Tanzania in 1985 to that in 1986?
Give a very brief answer. 0.31. What is the ratio of the Aid flow (current US$) in Burkina Faso in 1985 to that in 1987?
Offer a terse response. 0.61. What is the ratio of the Aid flow (current US$) in Jamaica in 1985 to that in 1987?
Your answer should be very brief. 0.6. What is the ratio of the Aid flow (current US$) in Tanzania in 1985 to that in 1987?
Keep it short and to the point. 0.36. What is the ratio of the Aid flow (current US$) of Burkina Faso in 1985 to that in 1988?
Offer a terse response. 0.46. What is the ratio of the Aid flow (current US$) of Jamaica in 1985 to that in 1988?
Provide a succinct answer. 0.13. What is the ratio of the Aid flow (current US$) in Tanzania in 1985 to that in 1988?
Give a very brief answer. 0.42. What is the ratio of the Aid flow (current US$) in Burkina Faso in 1986 to that in 1987?
Offer a very short reply. 0.9. What is the ratio of the Aid flow (current US$) of Jamaica in 1986 to that in 1987?
Make the answer very short. 0.8. What is the ratio of the Aid flow (current US$) of Tanzania in 1986 to that in 1987?
Your response must be concise. 1.13. What is the ratio of the Aid flow (current US$) in Burkina Faso in 1986 to that in 1988?
Offer a very short reply. 0.67. What is the ratio of the Aid flow (current US$) in Jamaica in 1986 to that in 1988?
Your response must be concise. 0.17. What is the ratio of the Aid flow (current US$) in Tanzania in 1986 to that in 1988?
Your answer should be very brief. 1.33. What is the ratio of the Aid flow (current US$) of Burkina Faso in 1987 to that in 1988?
Keep it short and to the point. 0.75. What is the ratio of the Aid flow (current US$) in Jamaica in 1987 to that in 1988?
Your response must be concise. 0.22. What is the ratio of the Aid flow (current US$) in Tanzania in 1987 to that in 1988?
Make the answer very short. 1.17. What is the difference between the highest and the second highest Aid flow (current US$) in Burkina Faso?
Make the answer very short. 1.01e+06. What is the difference between the highest and the second highest Aid flow (current US$) of Jamaica?
Offer a very short reply. 1.80e+05. What is the difference between the highest and the second highest Aid flow (current US$) in Tanzania?
Your answer should be compact. 2.26e+06. What is the difference between the highest and the lowest Aid flow (current US$) of Europe(all income levels)?
Provide a succinct answer. 1.09e+07. What is the difference between the highest and the lowest Aid flow (current US$) of Burkina Faso?
Provide a short and direct response. 2.42e+06. What is the difference between the highest and the lowest Aid flow (current US$) of Jamaica?
Provide a short and direct response. 2.20e+05. What is the difference between the highest and the lowest Aid flow (current US$) of Tanzania?
Give a very brief answer. 1.40e+07. 